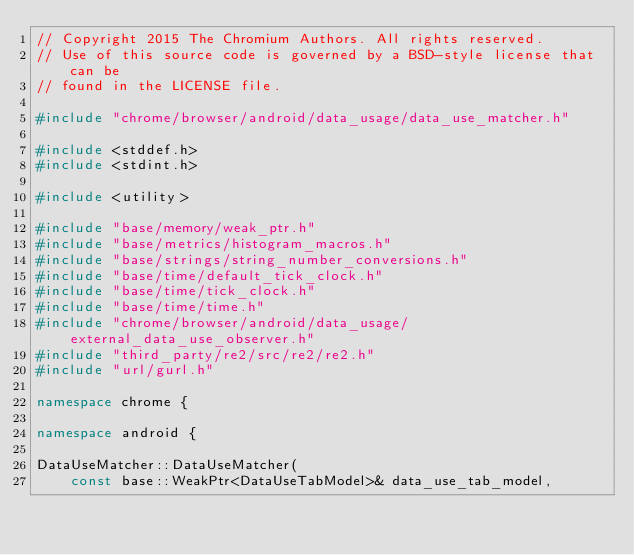<code> <loc_0><loc_0><loc_500><loc_500><_C++_>// Copyright 2015 The Chromium Authors. All rights reserved.
// Use of this source code is governed by a BSD-style license that can be
// found in the LICENSE file.

#include "chrome/browser/android/data_usage/data_use_matcher.h"

#include <stddef.h>
#include <stdint.h>

#include <utility>

#include "base/memory/weak_ptr.h"
#include "base/metrics/histogram_macros.h"
#include "base/strings/string_number_conversions.h"
#include "base/time/default_tick_clock.h"
#include "base/time/tick_clock.h"
#include "base/time/time.h"
#include "chrome/browser/android/data_usage/external_data_use_observer.h"
#include "third_party/re2/src/re2/re2.h"
#include "url/gurl.h"

namespace chrome {

namespace android {

DataUseMatcher::DataUseMatcher(
    const base::WeakPtr<DataUseTabModel>& data_use_tab_model,</code> 